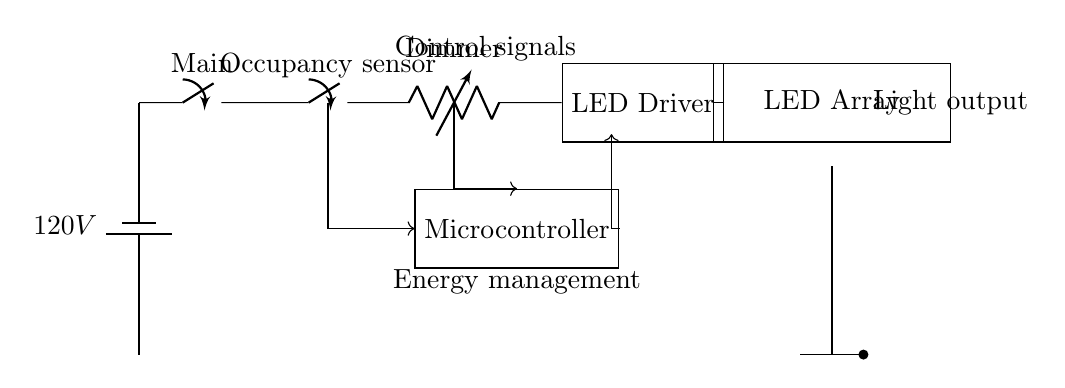What is the main power supply voltage in this circuit? The circuit diagram specifies a battery which supplies a voltage labeled as 120V at the top left corner.
Answer: 120V What component is responsible for adjusting the light intensity? The variable resistor, labeled as "Dimmer," is located in series with the LED driver and is used to control the intensity of the light output.
Answer: Dimmer Name the two control elements shown in the circuit. The circuit features an occupancy sensor, which detects presence, and a dimmer, which adjusts light intensity. Both are responsible for controlling the lighting based on user activity.
Answer: Occupancy sensor, Dimmer Which device converts the DC voltage to drive the LED array? The component labeled as "LED Driver" located next to the dimmer is responsible for converting the input voltage to the appropriate levels necessary to power the LED array effectively.
Answer: LED Driver How is the microcontroller connected to the dimmer and occupancy sensor? The microcontroller receives control signals from both the occupancy sensor and dimmer, indicated by arrows that connect them to the microcontroller. This highlights its role in processing inputs from these components.
Answer: Through control signals What is the purpose of the occupancy sensor in the circuit? The occupancy sensor detects whether a space is occupied or not, allowing it to signal the microcontroller to turn lights on or off based on presence, promoting energy efficiency.
Answer: Energy efficiency Which component is responsible for energy management in this circuit? The microcontroller is labeled with "Energy management," indicating it processes inputs and controls the output to manage energy consumption in the lighting system effectively.
Answer: Microcontroller 